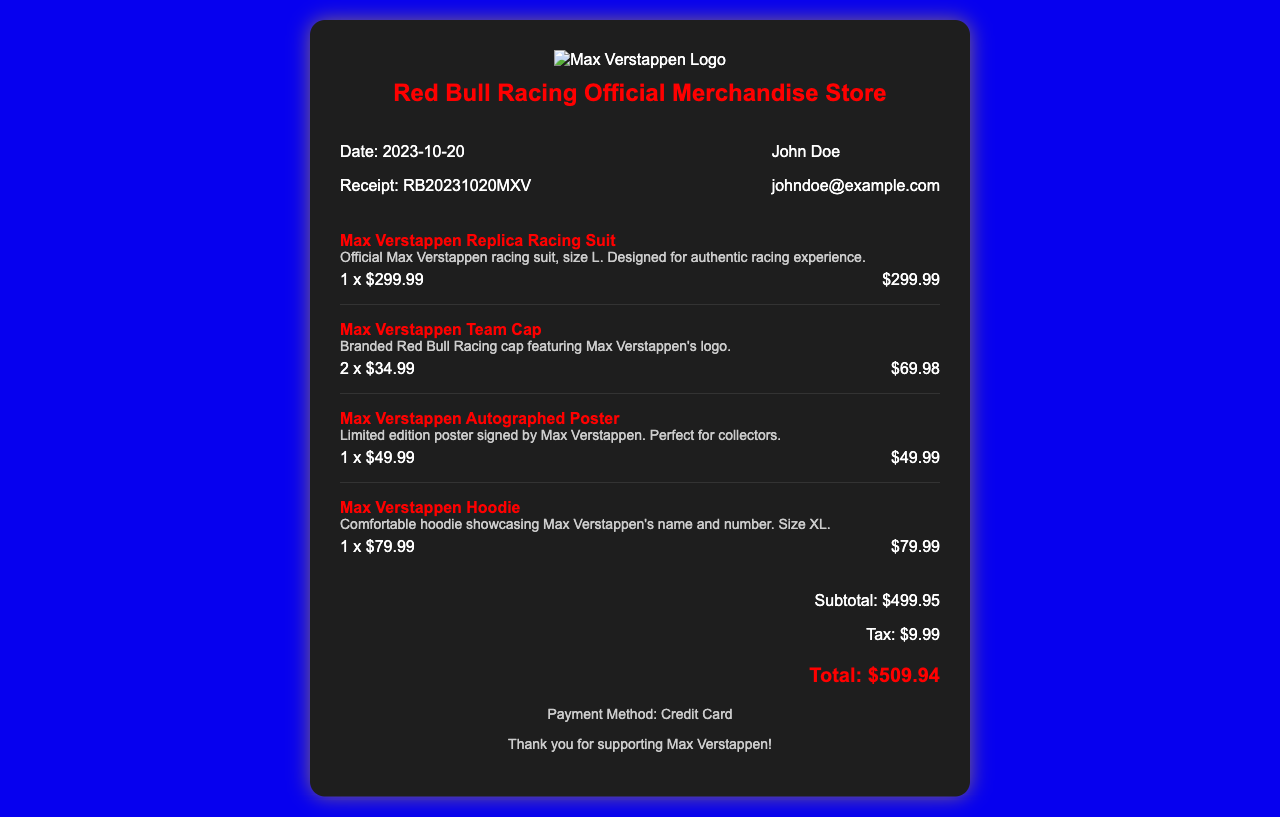What is the date of the receipt? The date of the receipt is explicitly mentioned in the document.
Answer: 2023-10-20 Who is the purchaser? The name of the purchaser is provided in the document.
Answer: John Doe What is the total amount? The total amount is listed in the totals section of the document.
Answer: $509.94 How many Max Verstappen Team Caps were purchased? The number of caps purchased can be found in the item section for this product.
Answer: 2 What is the price of the Max Verstappen Replica Racing Suit? The price of this specific item is noted in the document.
Answer: $299.99 What is the subtotal before tax? The subtotal is mentioned in the totals section of the receipt.
Answer: $499.95 What size is the Max Verstappen Hoodie? The size information for the hoodie is included in the item description.
Answer: XL What payment method was used? The payment method is specified in the footer of the document.
Answer: Credit Card How much tax was added to the purchase? The tax amount is provided in the totals section.
Answer: $9.99 